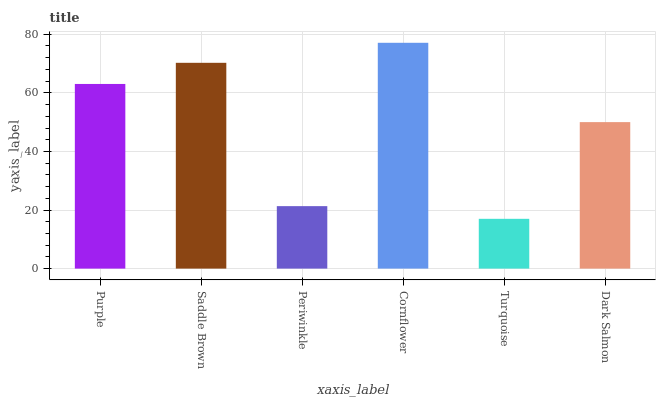Is Turquoise the minimum?
Answer yes or no. Yes. Is Cornflower the maximum?
Answer yes or no. Yes. Is Saddle Brown the minimum?
Answer yes or no. No. Is Saddle Brown the maximum?
Answer yes or no. No. Is Saddle Brown greater than Purple?
Answer yes or no. Yes. Is Purple less than Saddle Brown?
Answer yes or no. Yes. Is Purple greater than Saddle Brown?
Answer yes or no. No. Is Saddle Brown less than Purple?
Answer yes or no. No. Is Purple the high median?
Answer yes or no. Yes. Is Dark Salmon the low median?
Answer yes or no. Yes. Is Turquoise the high median?
Answer yes or no. No. Is Turquoise the low median?
Answer yes or no. No. 